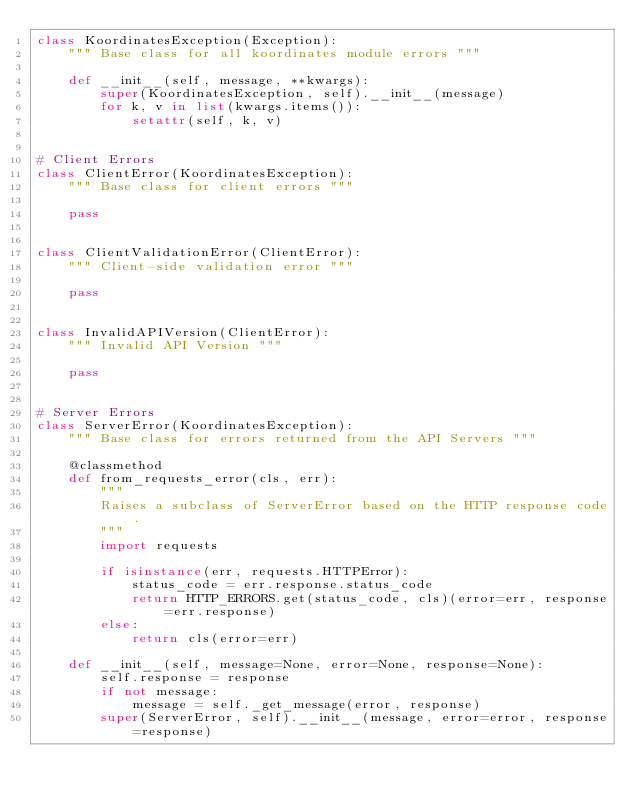<code> <loc_0><loc_0><loc_500><loc_500><_Python_>class KoordinatesException(Exception):
    """ Base class for all koordinates module errors """

    def __init__(self, message, **kwargs):
        super(KoordinatesException, self).__init__(message)
        for k, v in list(kwargs.items()):
            setattr(self, k, v)


# Client Errors
class ClientError(KoordinatesException):
    """ Base class for client errors """

    pass


class ClientValidationError(ClientError):
    """ Client-side validation error """

    pass


class InvalidAPIVersion(ClientError):
    """ Invalid API Version """

    pass


# Server Errors
class ServerError(KoordinatesException):
    """ Base class for errors returned from the API Servers """

    @classmethod
    def from_requests_error(cls, err):
        """
        Raises a subclass of ServerError based on the HTTP response code.
        """
        import requests

        if isinstance(err, requests.HTTPError):
            status_code = err.response.status_code
            return HTTP_ERRORS.get(status_code, cls)(error=err, response=err.response)
        else:
            return cls(error=err)

    def __init__(self, message=None, error=None, response=None):
        self.response = response
        if not message:
            message = self._get_message(error, response)
        super(ServerError, self).__init__(message, error=error, response=response)
</code> 